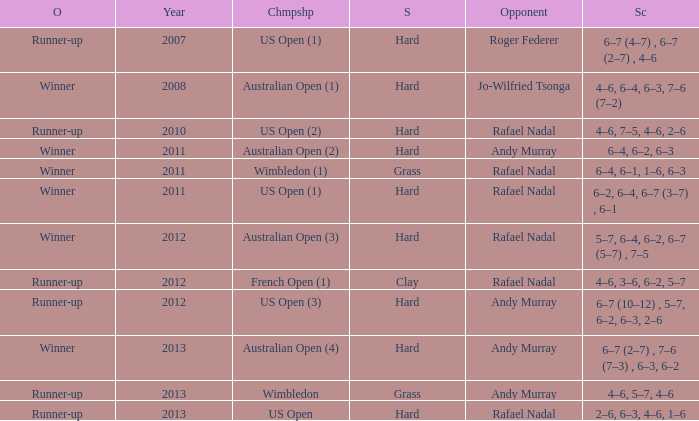What surface was the Australian Open (1) played on? Hard. Write the full table. {'header': ['O', 'Year', 'Chmpshp', 'S', 'Opponent', 'Sc'], 'rows': [['Runner-up', '2007', 'US Open (1)', 'Hard', 'Roger Federer', '6–7 (4–7) , 6–7 (2–7) , 4–6'], ['Winner', '2008', 'Australian Open (1)', 'Hard', 'Jo-Wilfried Tsonga', '4–6, 6–4, 6–3, 7–6 (7–2)'], ['Runner-up', '2010', 'US Open (2)', 'Hard', 'Rafael Nadal', '4–6, 7–5, 4–6, 2–6'], ['Winner', '2011', 'Australian Open (2)', 'Hard', 'Andy Murray', '6–4, 6–2, 6–3'], ['Winner', '2011', 'Wimbledon (1)', 'Grass', 'Rafael Nadal', '6–4, 6–1, 1–6, 6–3'], ['Winner', '2011', 'US Open (1)', 'Hard', 'Rafael Nadal', '6–2, 6–4, 6–7 (3–7) , 6–1'], ['Winner', '2012', 'Australian Open (3)', 'Hard', 'Rafael Nadal', '5–7, 6–4, 6–2, 6–7 (5–7) , 7–5'], ['Runner-up', '2012', 'French Open (1)', 'Clay', 'Rafael Nadal', '4–6, 3–6, 6–2, 5–7'], ['Runner-up', '2012', 'US Open (3)', 'Hard', 'Andy Murray', '6–7 (10–12) , 5–7, 6–2, 6–3, 2–6'], ['Winner', '2013', 'Australian Open (4)', 'Hard', 'Andy Murray', '6–7 (2–7) , 7–6 (7–3) , 6–3, 6–2'], ['Runner-up', '2013', 'Wimbledon', 'Grass', 'Andy Murray', '4–6, 5–7, 4–6'], ['Runner-up', '2013', 'US Open', 'Hard', 'Rafael Nadal', '2–6, 6–3, 4–6, 1–6']]} 